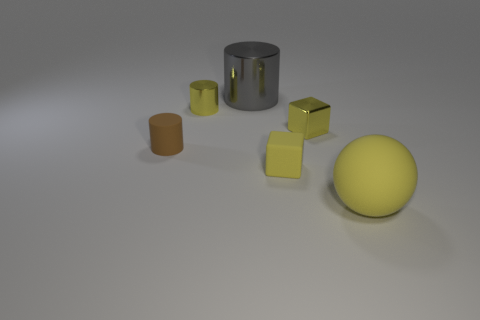Add 3 big shiny things. How many objects exist? 9 Subtract all spheres. How many objects are left? 5 Add 6 yellow objects. How many yellow objects exist? 10 Subtract 0 green cylinders. How many objects are left? 6 Subtract all small red metal balls. Subtract all yellow metal things. How many objects are left? 4 Add 4 tiny yellow metallic objects. How many tiny yellow metallic objects are left? 6 